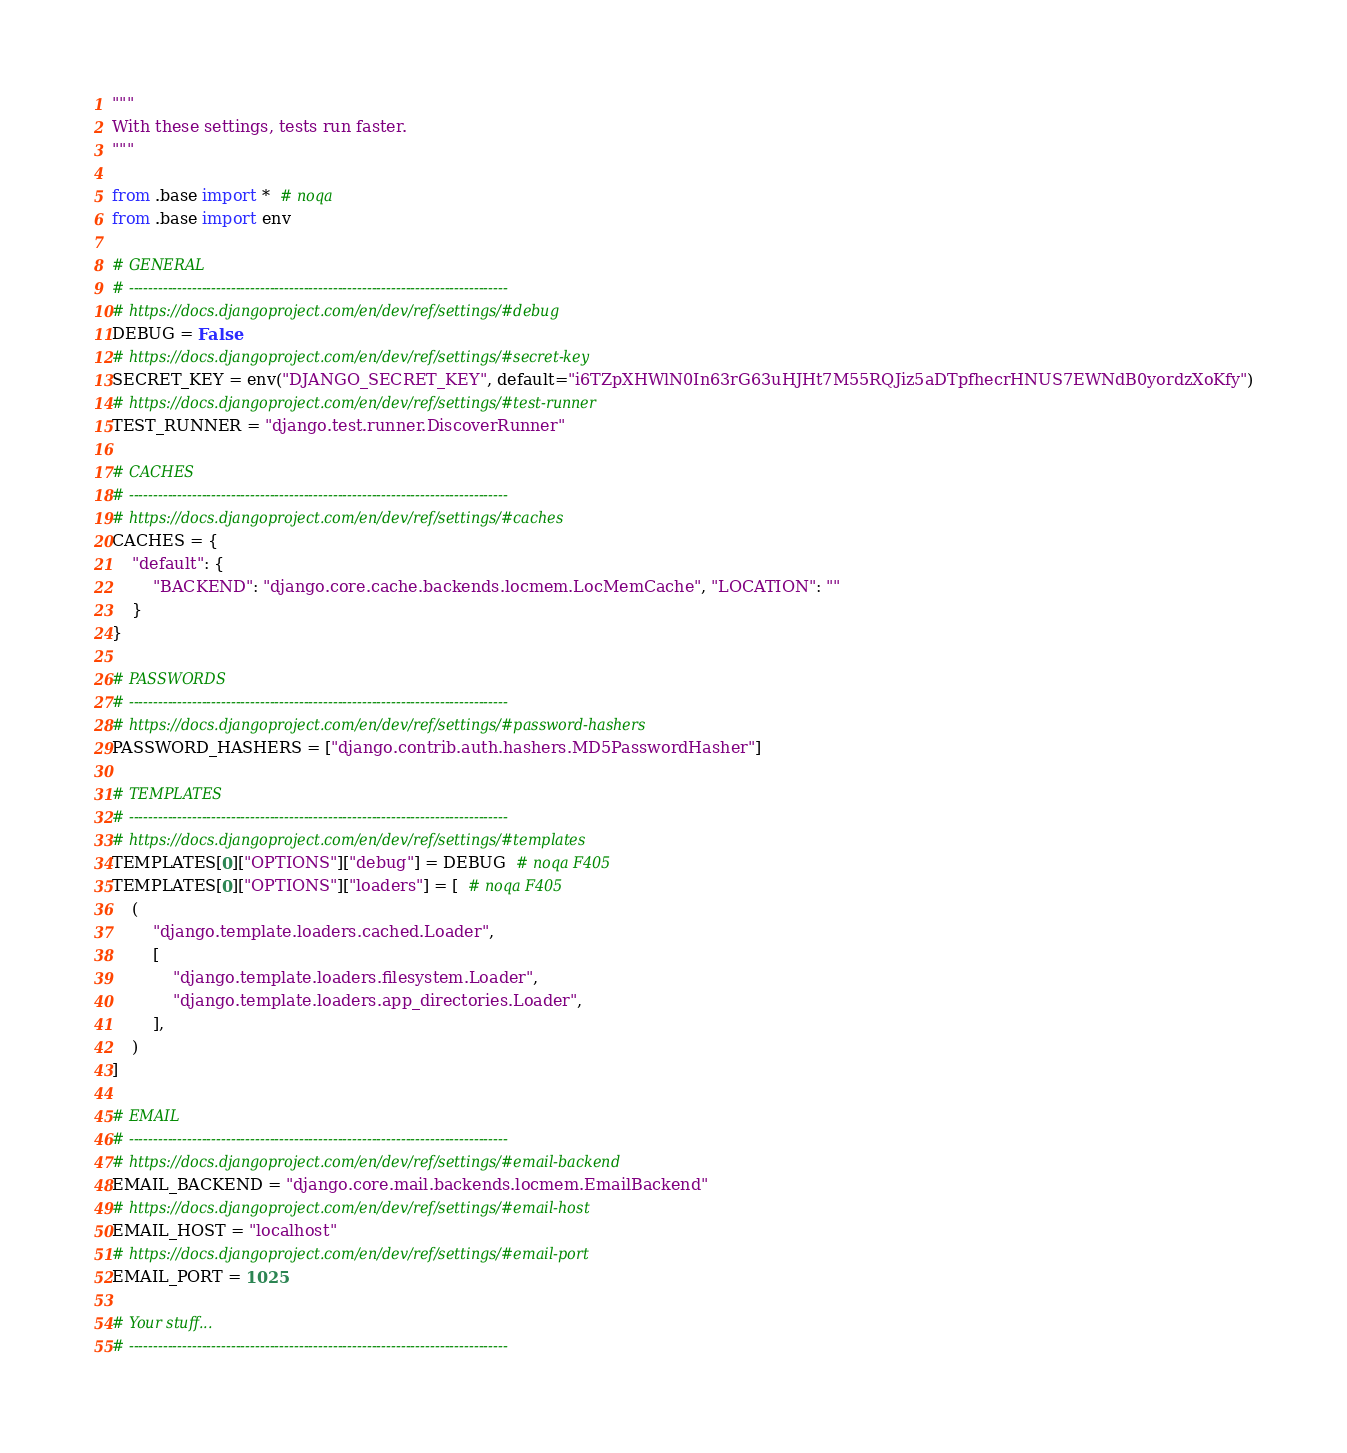<code> <loc_0><loc_0><loc_500><loc_500><_Python_>"""
With these settings, tests run faster.
"""

from .base import *  # noqa
from .base import env

# GENERAL
# ------------------------------------------------------------------------------
# https://docs.djangoproject.com/en/dev/ref/settings/#debug
DEBUG = False
# https://docs.djangoproject.com/en/dev/ref/settings/#secret-key
SECRET_KEY = env("DJANGO_SECRET_KEY", default="i6TZpXHWlN0In63rG63uHJHt7M55RQJiz5aDTpfhecrHNUS7EWNdB0yordzXoKfy")
# https://docs.djangoproject.com/en/dev/ref/settings/#test-runner
TEST_RUNNER = "django.test.runner.DiscoverRunner"

# CACHES
# ------------------------------------------------------------------------------
# https://docs.djangoproject.com/en/dev/ref/settings/#caches
CACHES = {
    "default": {
        "BACKEND": "django.core.cache.backends.locmem.LocMemCache", "LOCATION": ""
    }
}

# PASSWORDS
# ------------------------------------------------------------------------------
# https://docs.djangoproject.com/en/dev/ref/settings/#password-hashers
PASSWORD_HASHERS = ["django.contrib.auth.hashers.MD5PasswordHasher"]

# TEMPLATES
# ------------------------------------------------------------------------------
# https://docs.djangoproject.com/en/dev/ref/settings/#templates
TEMPLATES[0]["OPTIONS"]["debug"] = DEBUG  # noqa F405
TEMPLATES[0]["OPTIONS"]["loaders"] = [  # noqa F405
    (
        "django.template.loaders.cached.Loader",
        [
            "django.template.loaders.filesystem.Loader",
            "django.template.loaders.app_directories.Loader",
        ],
    )
]

# EMAIL
# ------------------------------------------------------------------------------
# https://docs.djangoproject.com/en/dev/ref/settings/#email-backend
EMAIL_BACKEND = "django.core.mail.backends.locmem.EmailBackend"
# https://docs.djangoproject.com/en/dev/ref/settings/#email-host
EMAIL_HOST = "localhost"
# https://docs.djangoproject.com/en/dev/ref/settings/#email-port
EMAIL_PORT = 1025

# Your stuff...
# ------------------------------------------------------------------------------
</code> 